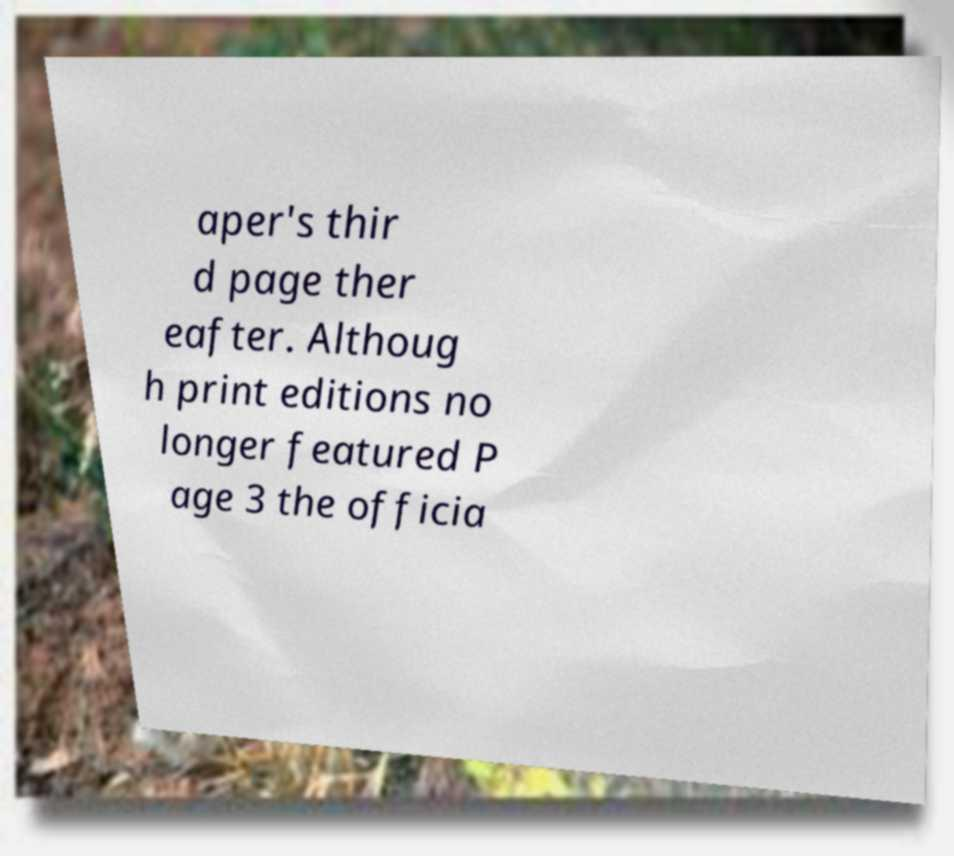Please read and relay the text visible in this image. What does it say? aper's thir d page ther eafter. Althoug h print editions no longer featured P age 3 the officia 